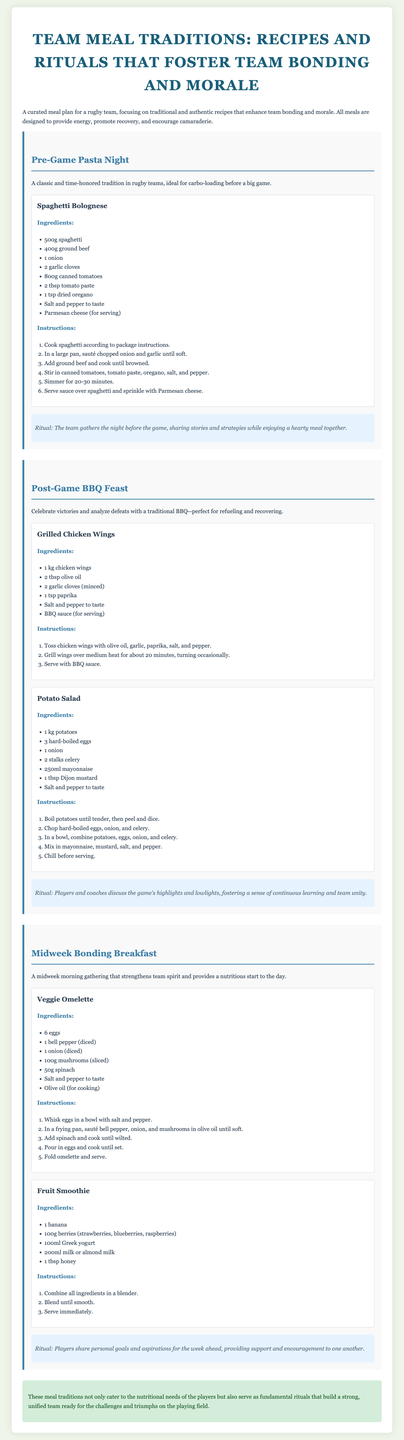what is the title of the document? The title is prominently displayed at the top of the document as the main heading.
Answer: Team Meal Traditions: Recipes and Rituals that Foster Team Bonding and Morale how many recipes are included in the Post-Game BBQ Feast section? The Post-Game BBQ Feast section includes two recipes listed under it.
Answer: 2 what meal tradition is celebrated after a game? The document describes a specific meal tradition that occurs post-game, focusing on victory and reflection.
Answer: Post-Game BBQ Feast which meal is designed for carbo-loading? This meal focuses on providing energy through carbohydrates before a big game.
Answer: Pre-Game Pasta Night what is the main ingredient in the Veggie Omelette recipe? The Veggie Omelette recipe highlights a specific ingredient as the primary component of the dish.
Answer: Eggs what do players do during the Midweek Bonding Breakfast ritual? This ritual includes sharing personal goals and aspirations, fostering support among team members.
Answer: Support and encouragement which food item is served with the Grilled Chicken Wings? The accompanying food served with the Grilled Chicken Wings is mentioned in the recipe section.
Answer: BBQ sauce how does the Pre-Game Pasta Night enhance team bonding? The document states the purpose of gathering for this meal, indicating the benefits it provides for team cohesion.
Answer: Sharing stories and strategies what are the ingredients in the Fruit Smoothie? The Fruit Smoothie recipe details specific ingredients used to create the drink.
Answer: Banana, berries, Greek yogurt, milk, honey 